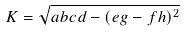<formula> <loc_0><loc_0><loc_500><loc_500>K = \sqrt { a b c d - ( e g - f h ) ^ { 2 } }</formula> 